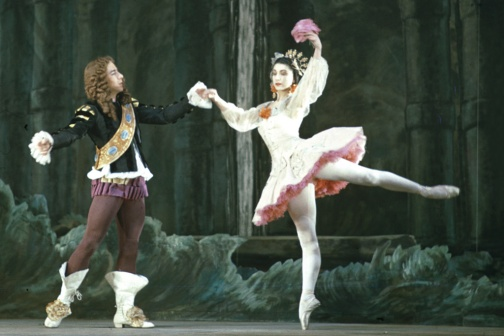What story do you think these dancers are telling? The dancers appear to be telling a timeless story of love and destiny. The male dancer's outstretched arms suggest a beckoning or call to adventure, potentially inviting the female dancer to join him on a journey or to solidify a romantic bond. Her mid-leap position, graceful yet powerful, signifies acceptance and an embracement of this invitation. This scene, captured in a moment of movement, might be part of a larger narrative involving trials, separation, and eventual reunion, common themes in the world of ballet where movements speak volumes. 